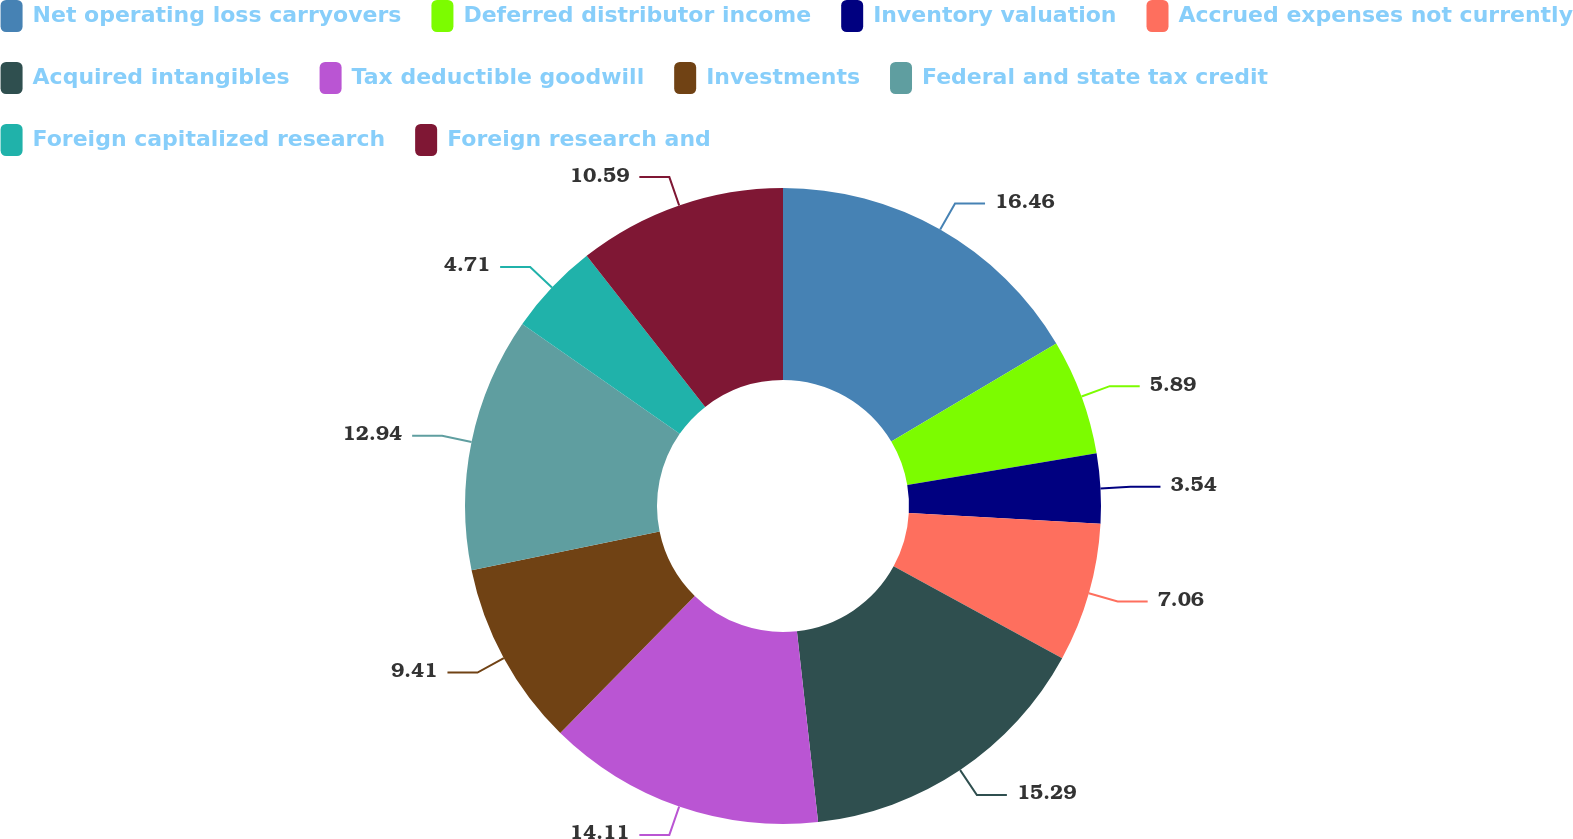<chart> <loc_0><loc_0><loc_500><loc_500><pie_chart><fcel>Net operating loss carryovers<fcel>Deferred distributor income<fcel>Inventory valuation<fcel>Accrued expenses not currently<fcel>Acquired intangibles<fcel>Tax deductible goodwill<fcel>Investments<fcel>Federal and state tax credit<fcel>Foreign capitalized research<fcel>Foreign research and<nl><fcel>16.46%<fcel>5.89%<fcel>3.54%<fcel>7.06%<fcel>15.29%<fcel>14.11%<fcel>9.41%<fcel>12.94%<fcel>4.71%<fcel>10.59%<nl></chart> 